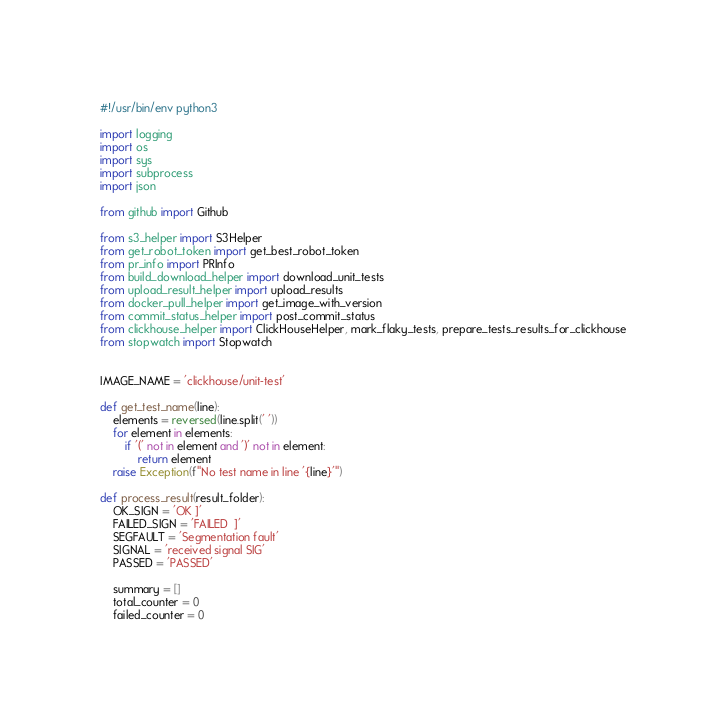<code> <loc_0><loc_0><loc_500><loc_500><_Python_>#!/usr/bin/env python3

import logging
import os
import sys
import subprocess
import json

from github import Github

from s3_helper import S3Helper
from get_robot_token import get_best_robot_token
from pr_info import PRInfo
from build_download_helper import download_unit_tests
from upload_result_helper import upload_results
from docker_pull_helper import get_image_with_version
from commit_status_helper import post_commit_status
from clickhouse_helper import ClickHouseHelper, mark_flaky_tests, prepare_tests_results_for_clickhouse
from stopwatch import Stopwatch


IMAGE_NAME = 'clickhouse/unit-test'

def get_test_name(line):
    elements = reversed(line.split(' '))
    for element in elements:
        if '(' not in element and ')' not in element:
            return element
    raise Exception(f"No test name in line '{line}'")

def process_result(result_folder):
    OK_SIGN = 'OK ]'
    FAILED_SIGN = 'FAILED  ]'
    SEGFAULT = 'Segmentation fault'
    SIGNAL = 'received signal SIG'
    PASSED = 'PASSED'

    summary = []
    total_counter = 0
    failed_counter = 0</code> 